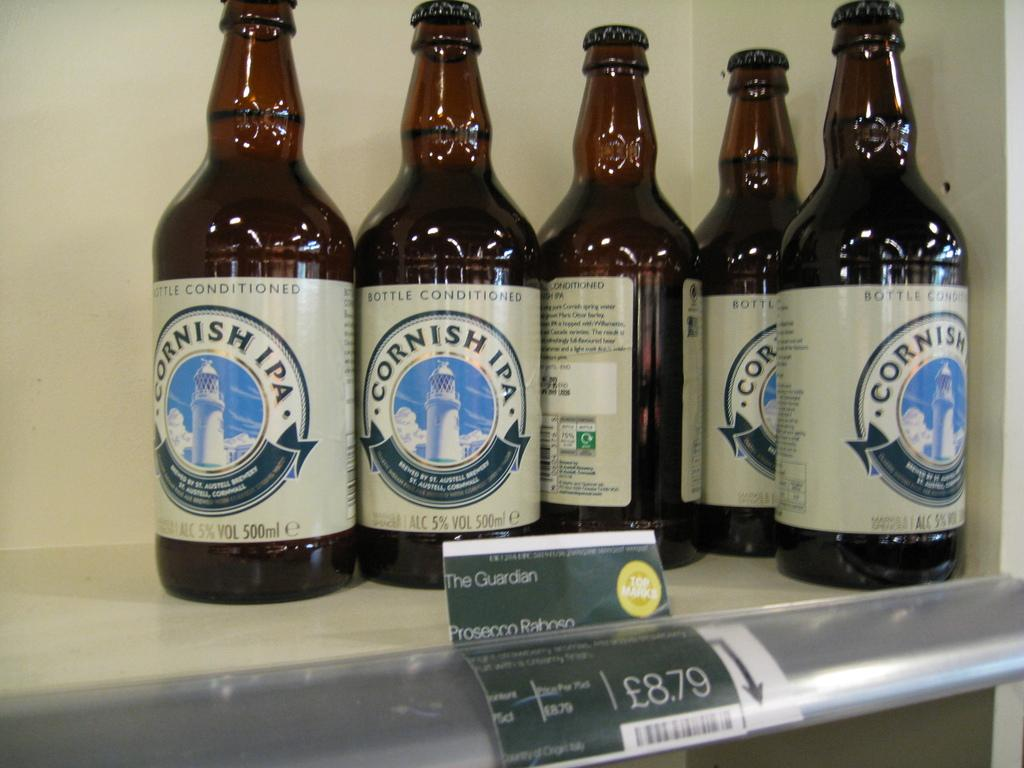Provide a one-sentence caption for the provided image. five bottles on a store shelf of Cornish IPA Beer. 